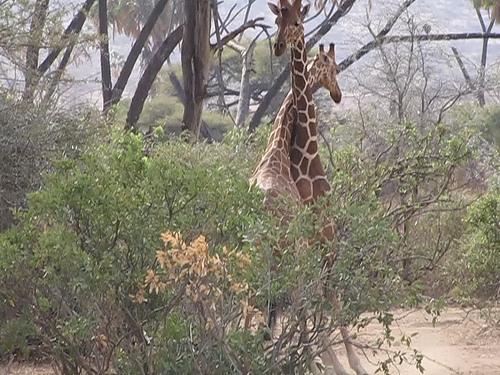How many giraffe are walking in the forest?
Give a very brief answer. 2. How many birds are pictured?
Answer briefly. 0. Are the giraffes touching each other?
Write a very short answer. Yes. What color are these animals?
Give a very brief answer. Brown. Do these giraffes like each other?
Give a very brief answer. Yes. Can you see the animals head?
Be succinct. Yes. How many animals are there?
Give a very brief answer. 2. 